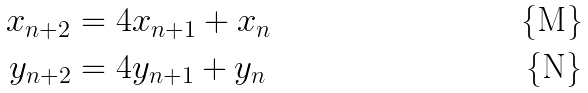<formula> <loc_0><loc_0><loc_500><loc_500>x _ { n + 2 } & = 4 x _ { n + 1 } + x _ { n } \\ y _ { n + 2 } & = 4 y _ { n + 1 } + y _ { n }</formula> 